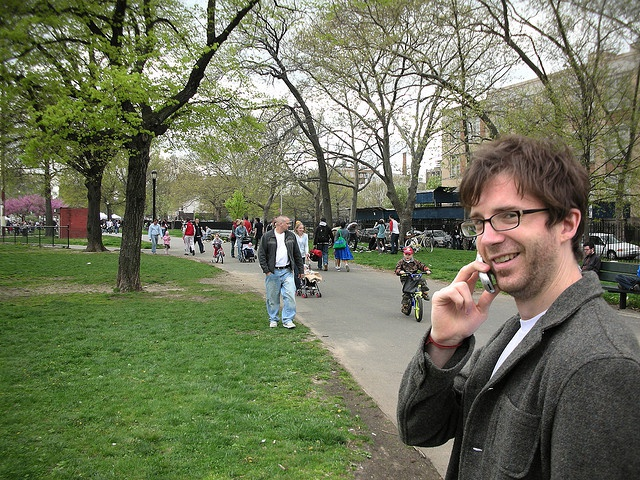Describe the objects in this image and their specific colors. I can see people in darkgreen, black, gray, and lightpink tones, people in darkgreen, black, gray, darkgray, and lightgray tones, people in darkgreen, black, gray, white, and darkgray tones, people in darkgreen, black, gray, and darkgray tones, and car in darkgreen, black, gray, darkgray, and white tones in this image. 